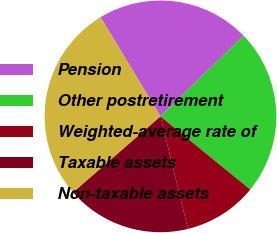Convert chart. <chart><loc_0><loc_0><loc_500><loc_500><pie_chart><fcel>Pension<fcel>Other postretirement<fcel>Weighted-average rate of<fcel>Taxable assets<fcel>Non-taxable assets<nl><fcel>21.39%<fcel>23.14%<fcel>10.3%<fcel>17.43%<fcel>27.73%<nl></chart> 